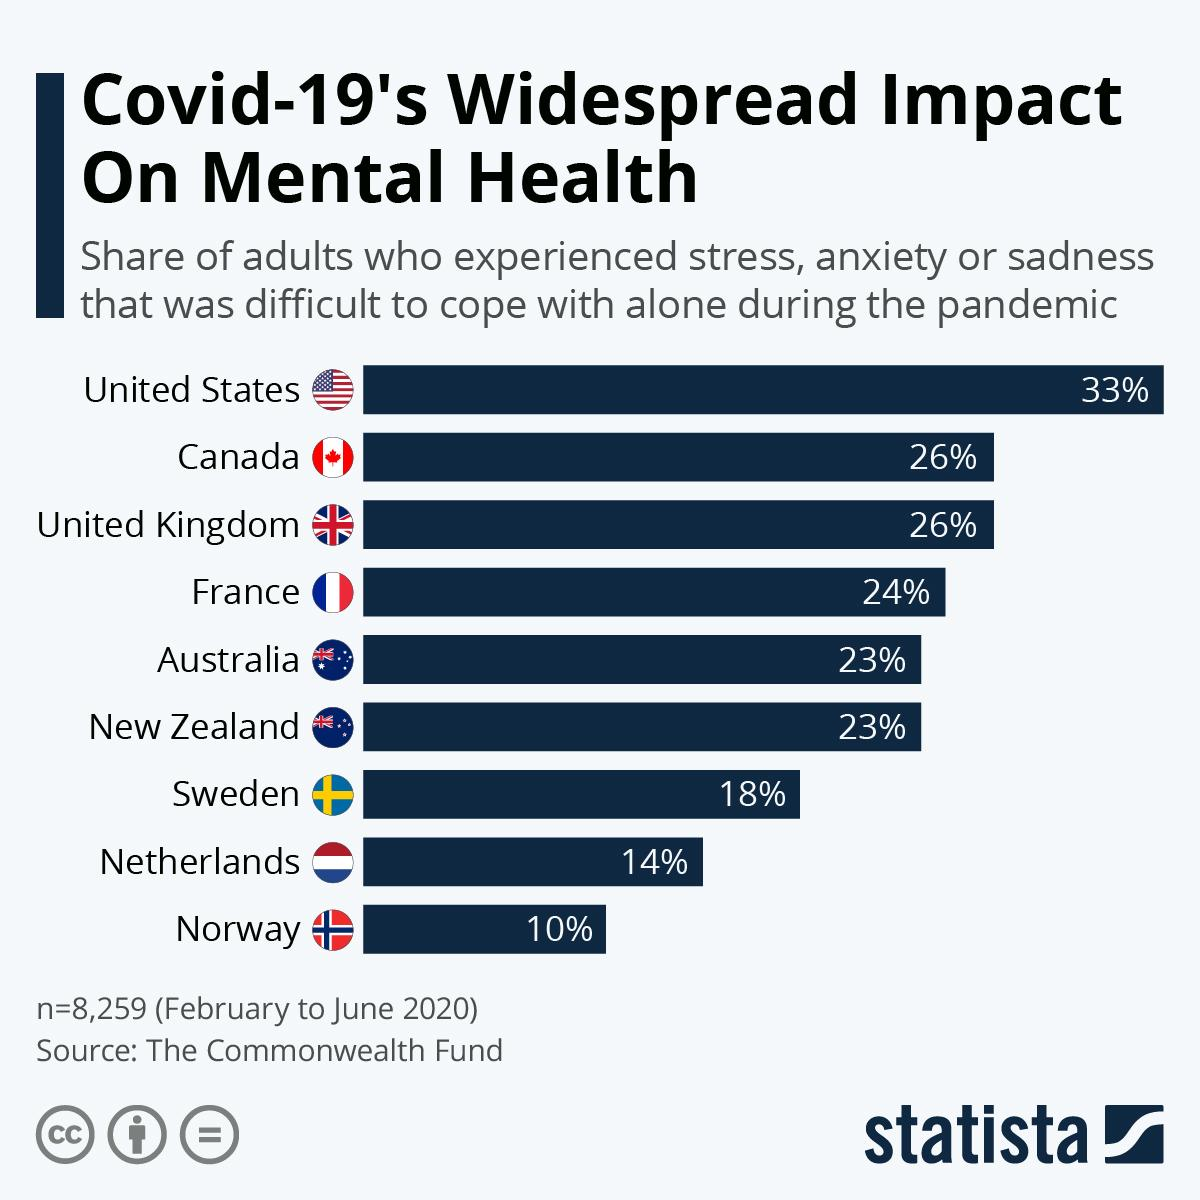Indicate a few pertinent items in this graphic. In the Netherlands and Norway, approximately 24% of adults reported experiencing stress and anxiety. Eight thousand, two hundred and fifty-nine adults were surveyed in total. The survey was taken between February and June of 2020. According to the data, Canada and the United Kingdom share a similar percentage of adults who experience stress. 